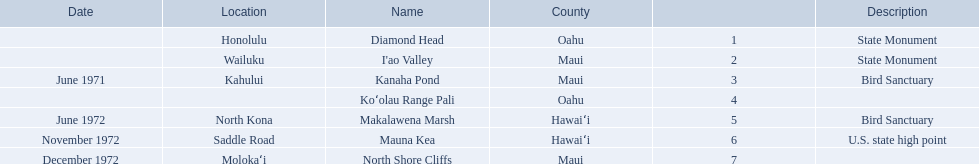What are the names of the different hawaiian national landmarks Diamond Head, I'ao Valley, Kanaha Pond, Koʻolau Range Pali, Makalawena Marsh, Mauna Kea, North Shore Cliffs. Which landmark does not have a location listed? Koʻolau Range Pali. 